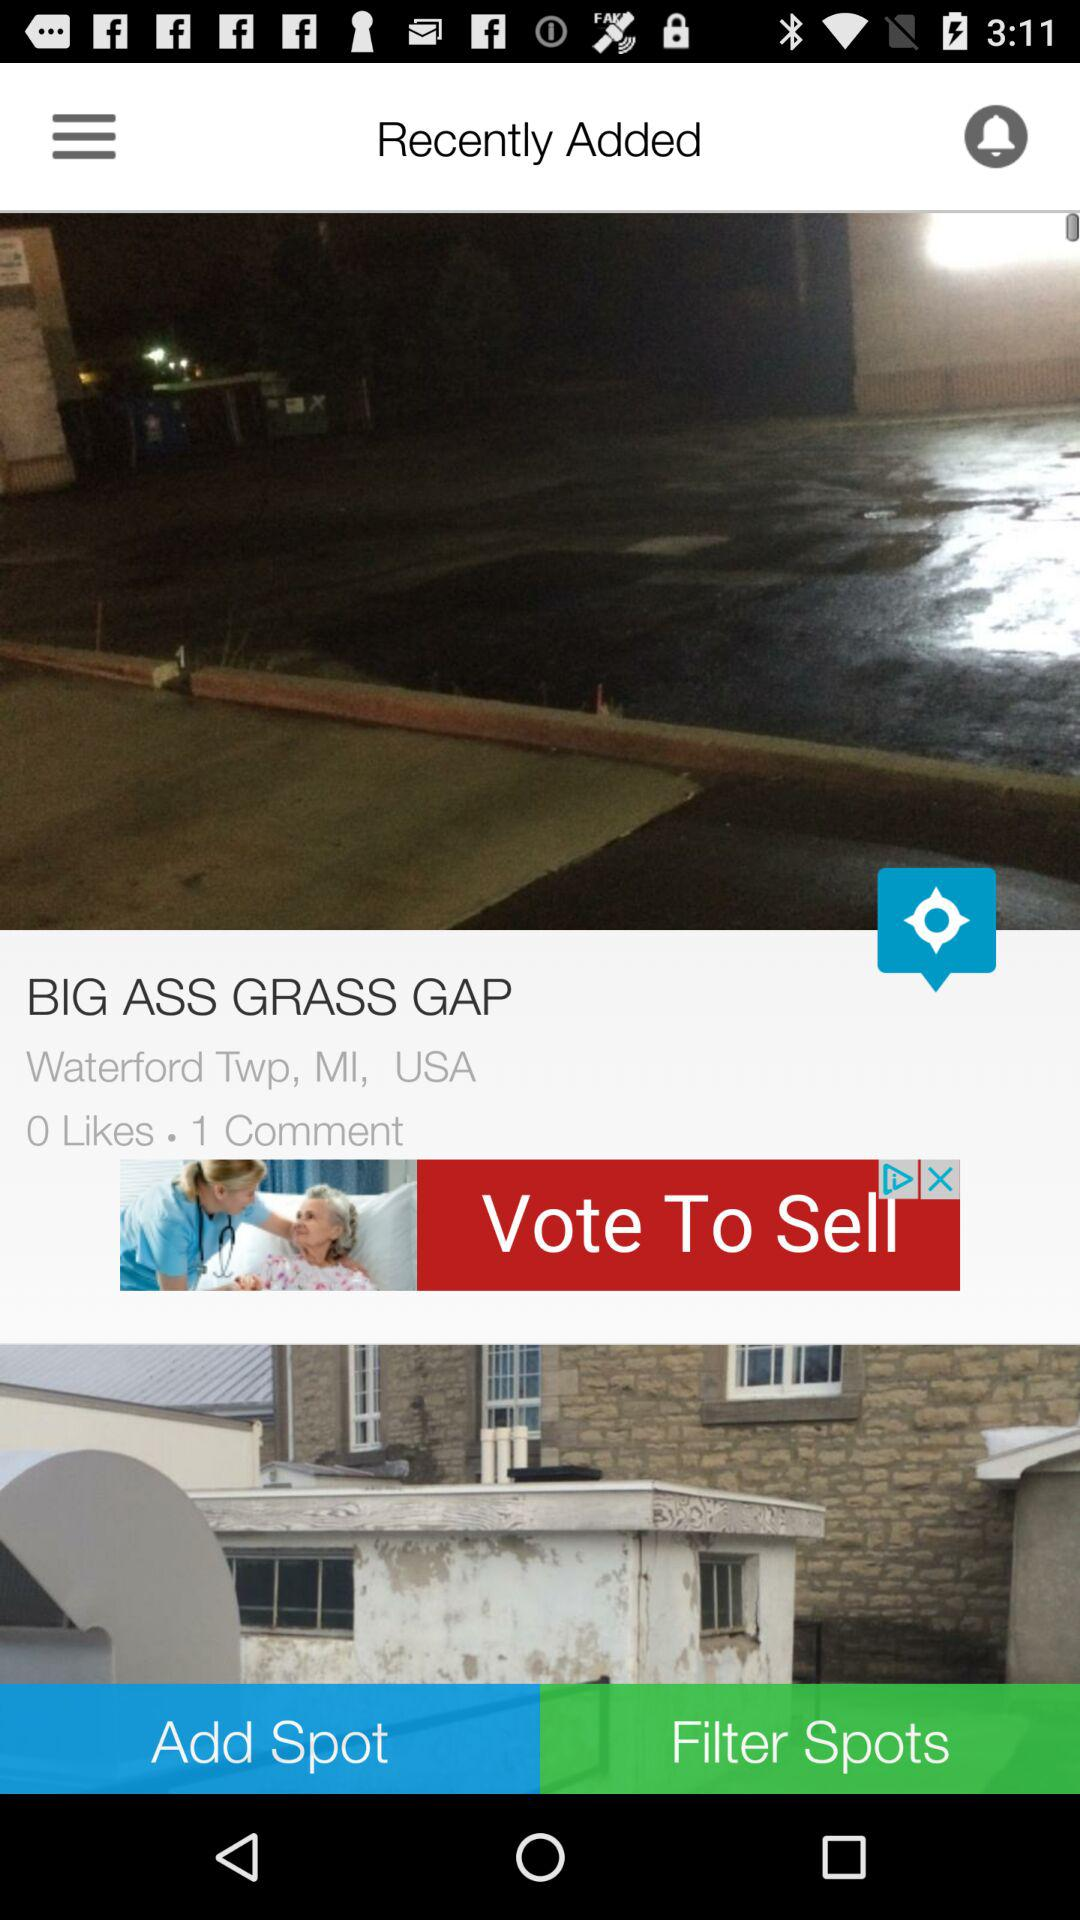How many more comments than likes does the spot have?
Answer the question using a single word or phrase. 1 